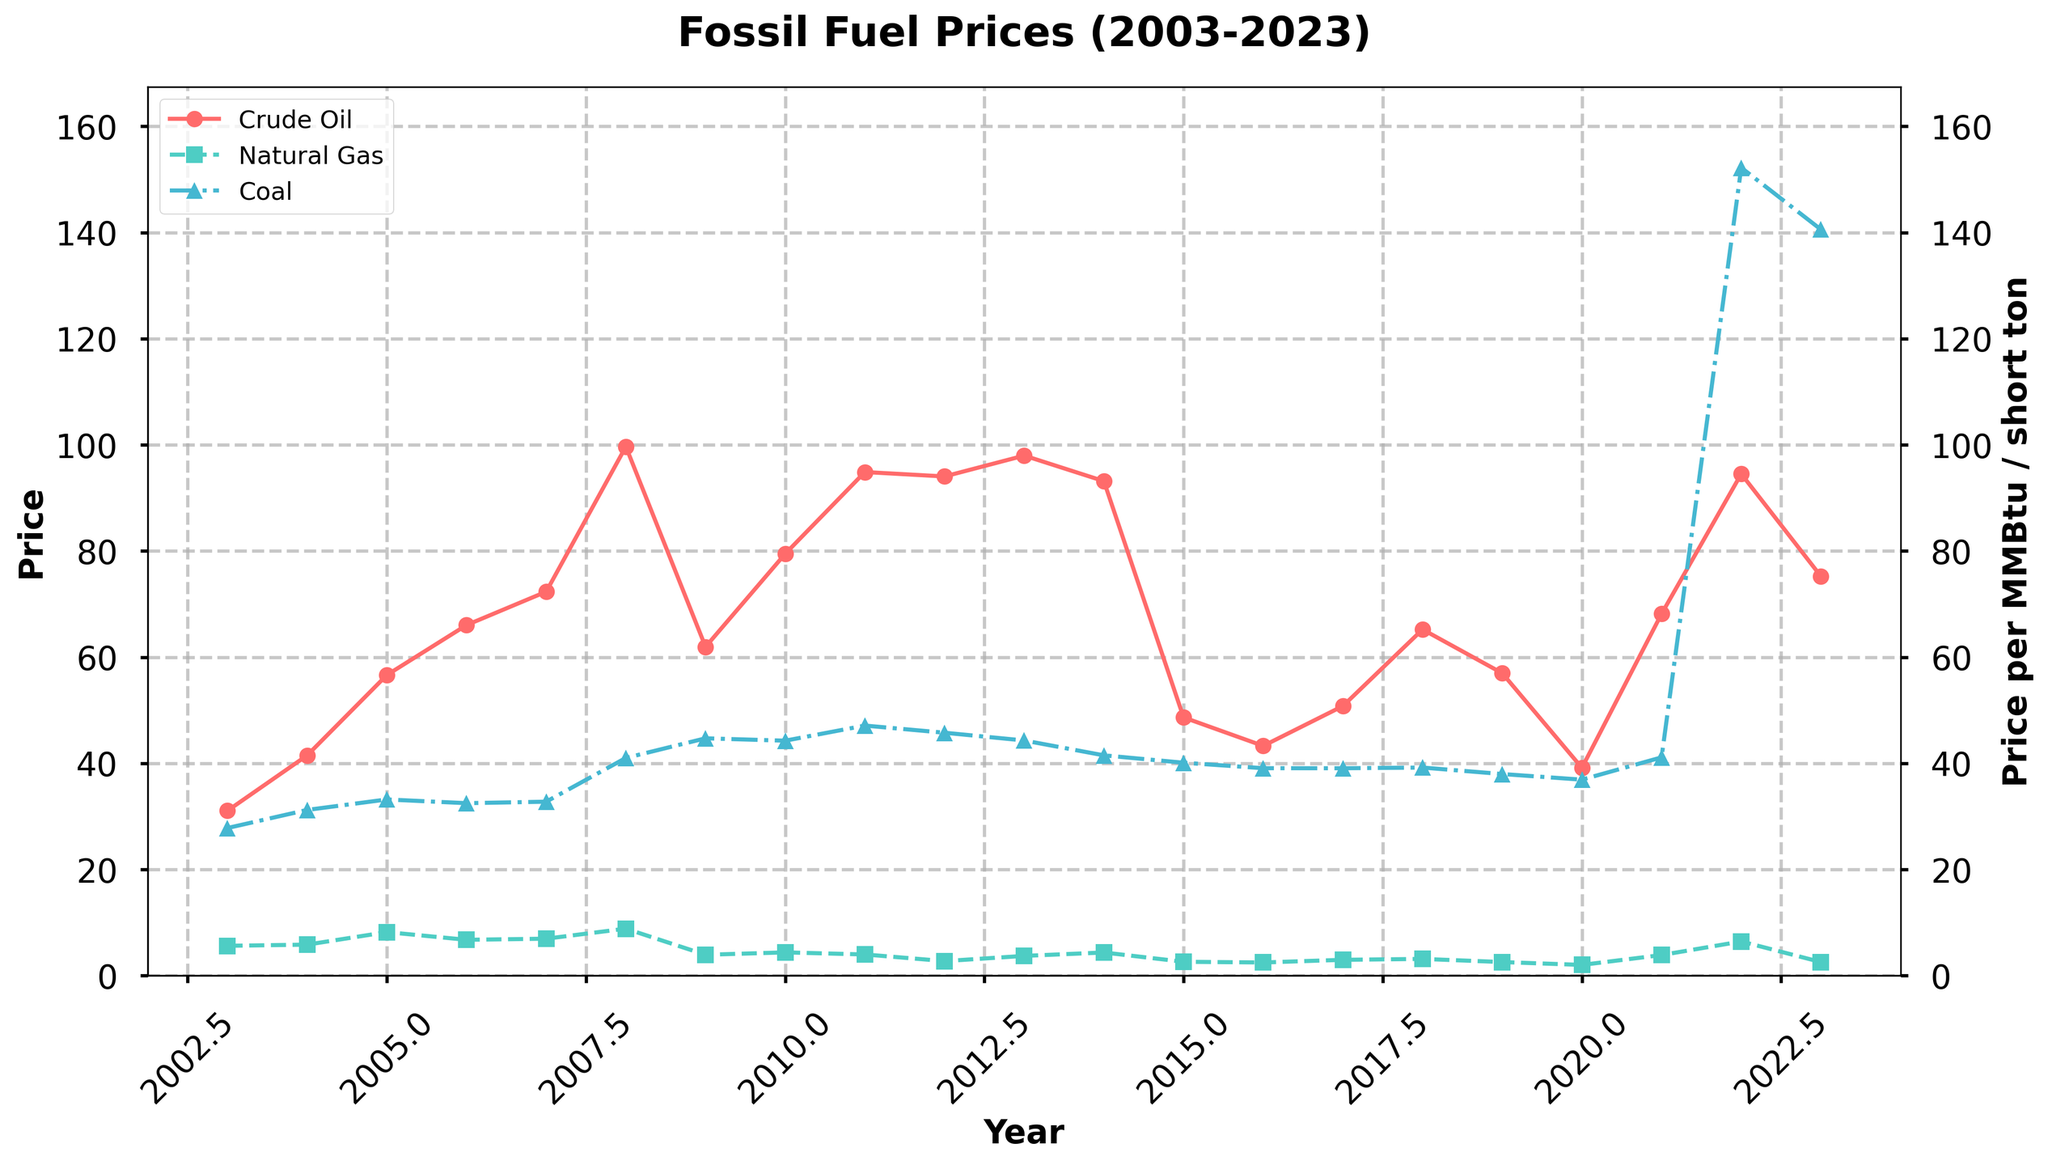Which fossil fuel had the highest price in 2008? From the chart, observe the peak points for each fossil fuel in 2008. Crude oil had the highest price among them, surpassing the others.
Answer: Crude Oil Which year did coal price experience the largest increase compared to the previous year? Examine the slope of the coal price line. The steepest increase occurs from 2021 to 2022, indicating the largest price increase in coal during this period.
Answer: 2022 How does the price of crude oil in 2023 compare to its peak price within the span? Identify the peak of the crude oil price, which occurs in 2008 at $99.67/barrel, and compare it to 2023's price of $75.24/barrel. The 2023 price is lower than the peak.
Answer: Lower What is the average price of natural gas over the first 5 years (2003-2007)? Add the natural gas prices for 2003 to 2007 and divide by 5. (5.63 + 5.85 + 8.21 + 6.76 + 6.97) / 5 = 6.684.
Answer: 6.684 Which year had the lowest crude oil price and what was it? Look at the lowest point on the crude oil price line. The lowest price is in 2020, where it dropped to $39.16/barrel.
Answer: 2020, $39.16/barrel By how much did the coal price change from 2021 to 2022? Check the coal prices for 2021 and 2022. The change is 152.22 - 41.13 = 111.09.
Answer: 111.09 Did natural gas prices ever surpass the $8/MMBtu mark? If so, in which years? Look for points on the natural gas price line that exceed $8/MMBtu. This occurred in 2005 and 2008.
Answer: 2005, 2008 How many years did natural gas have lower prices than coal prices? Compare every year in the dataset to count how many years the natural gas price was lower than the coal price. This happened in 2009-2014, 2017-2019, 2020, 2023, totaling 11 years.
Answer: 11 years In which year did crude oil, natural gas, and coal prices all see a decline compared to the previous year? Look for years where all three lines are trending downwards. This happens in 2015 and 2016.
Answer: 2015, 2016 